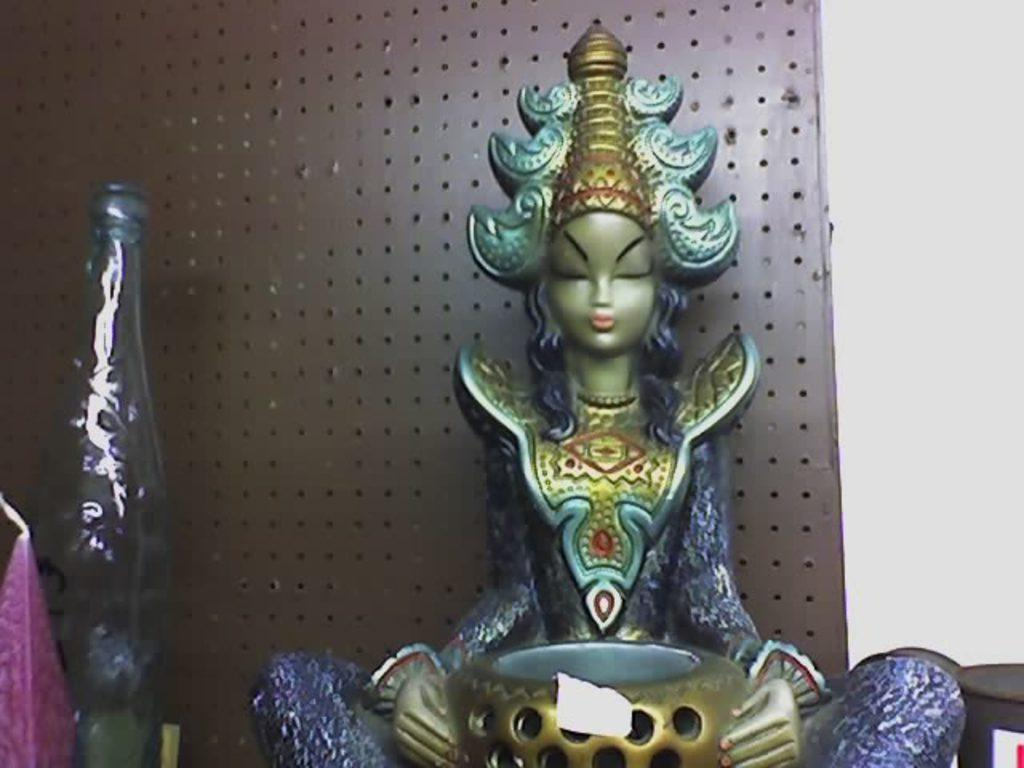What is the main subject of the image? There is an idol in the image. What color is the idol? The idol is blue in color. What color is the background wall in the image? The background wall is brown. What type of brass structure can be seen near the idol in the image? There is no brass structure present in the image. Is there a church visible in the background of the image? There is no church visible in the image; it only features an idol and a brown background wall. 